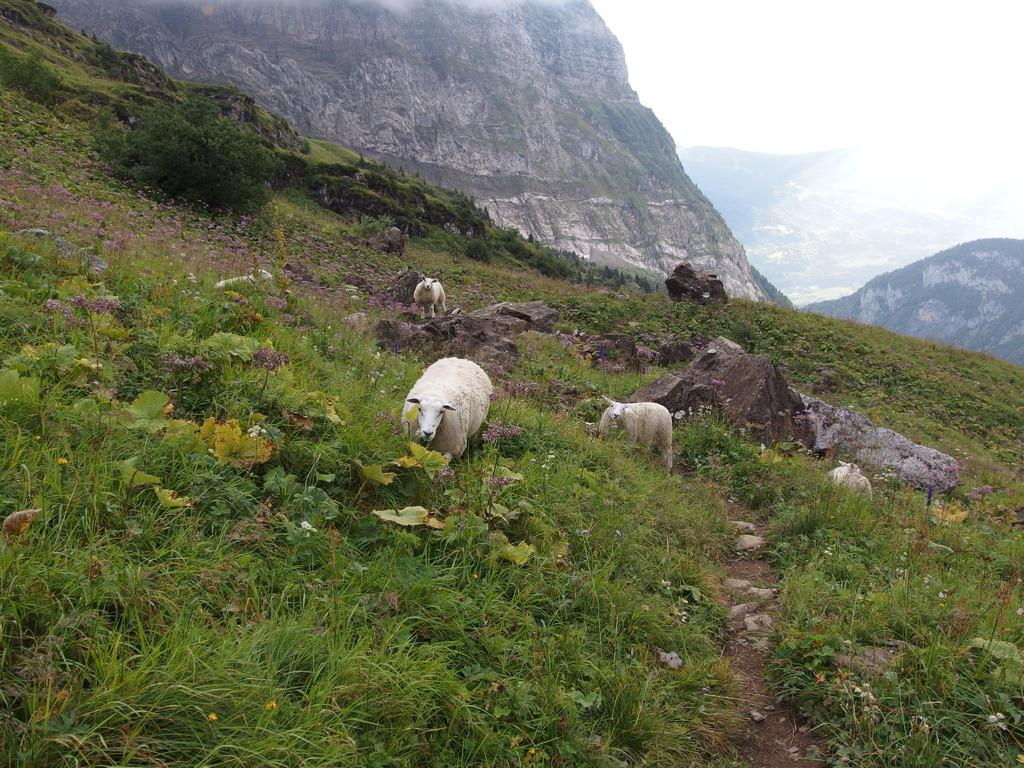What animals are in the center of the image? There are goats in the center of the image. What type of landscape can be seen in the background of the image? There are mountains in the background of the image. What type of vegetation is present on the ground in the image? Grass is present on the ground in the image. What is the condition of the sky in the image? The sky is cloudy in the image. What color is the shirt worn by the chicken in the image? There is no chicken or shirt present in the image; it features goats and a cloudy sky. 